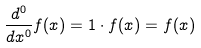<formula> <loc_0><loc_0><loc_500><loc_500>\frac { d ^ { 0 } } { d x ^ { 0 } } f ( x ) = 1 \cdot f ( x ) = f ( x )</formula> 